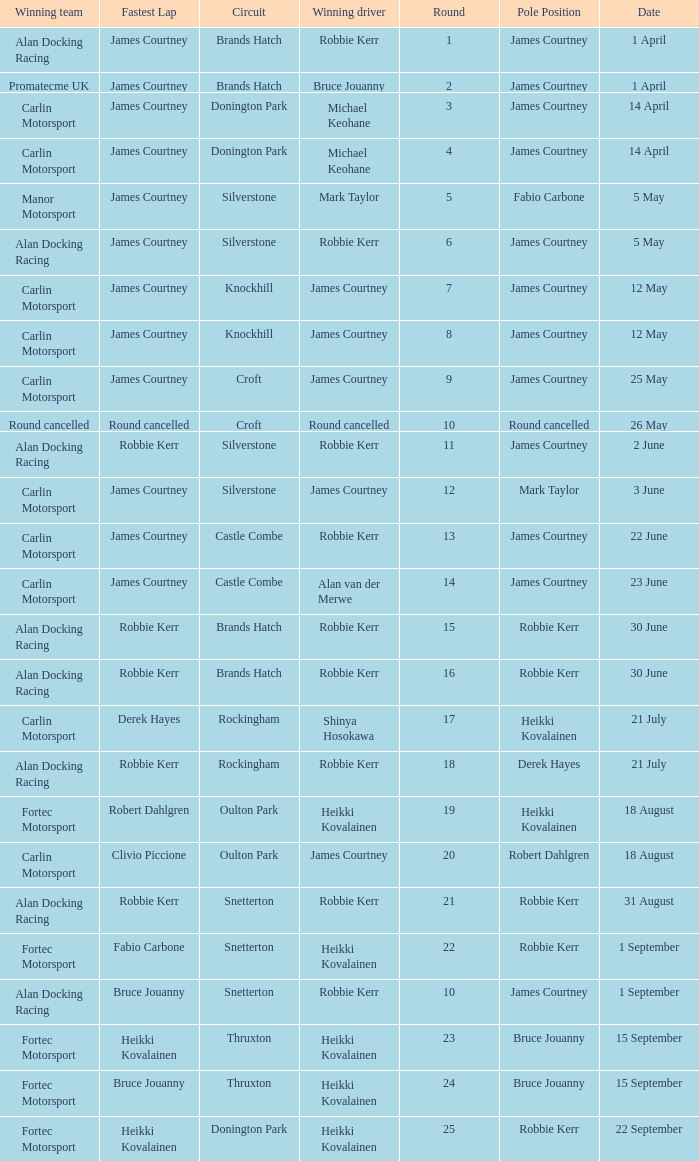Who are all winning drivers if winning team is Carlin Motorsport and circuit is Croft? James Courtney. 